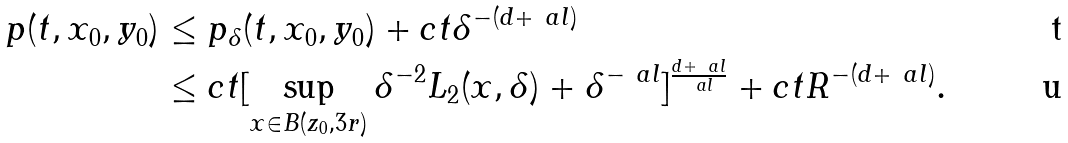<formula> <loc_0><loc_0><loc_500><loc_500>p ( t , x _ { 0 } , y _ { 0 } ) & \leq p _ { \delta } ( t , x _ { 0 } , y _ { 0 } ) + c t \delta ^ { - ( d + \ a l ) } \\ & \leq c t [ \sup _ { x \in B ( z _ { 0 } , 3 r ) } \delta ^ { - 2 } L _ { 2 } ( x , \delta ) + \delta ^ { - \ a l } ] ^ { \frac { d + \ a l } { \ a l } } + c t R ^ { - ( d + \ a l ) } .</formula> 